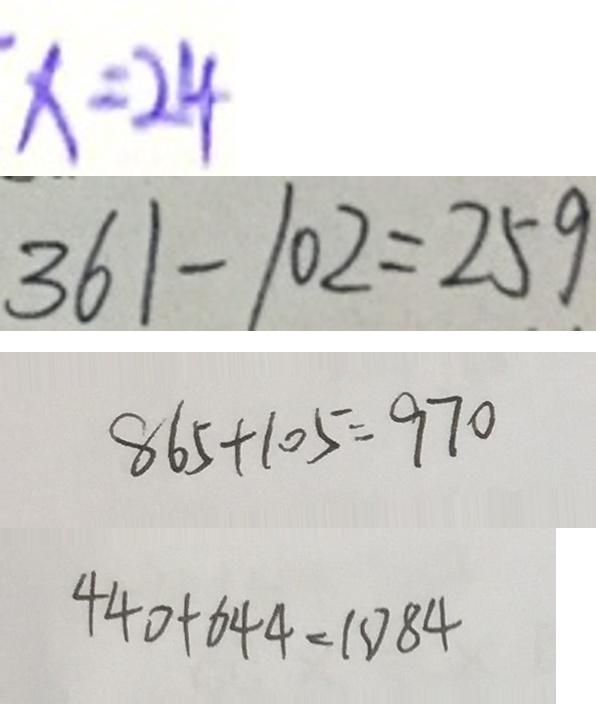<formula> <loc_0><loc_0><loc_500><loc_500>x = 2 4 
 3 6 1 - 1 0 2 = 2 5 9 
 8 6 5 + 1 0 5 = 9 7 0 
 4 4 0 + 6 4 4 = 1 0 8 4</formula> 